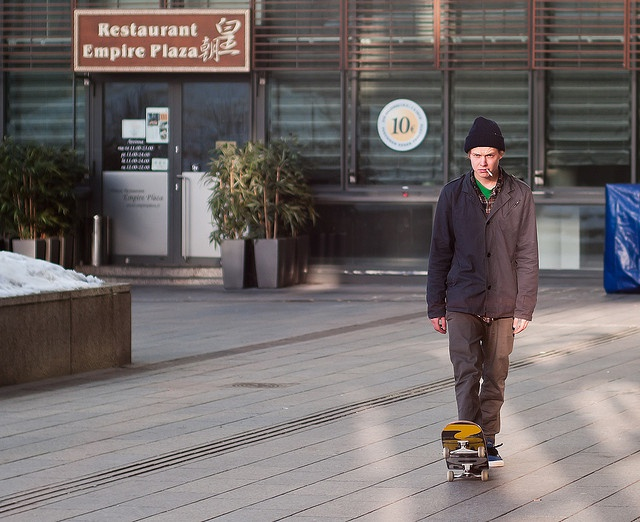Describe the objects in this image and their specific colors. I can see people in black, gray, and brown tones, potted plant in black, gray, and maroon tones, potted plant in black, gray, and darkgreen tones, and skateboard in black, gray, orange, and maroon tones in this image. 